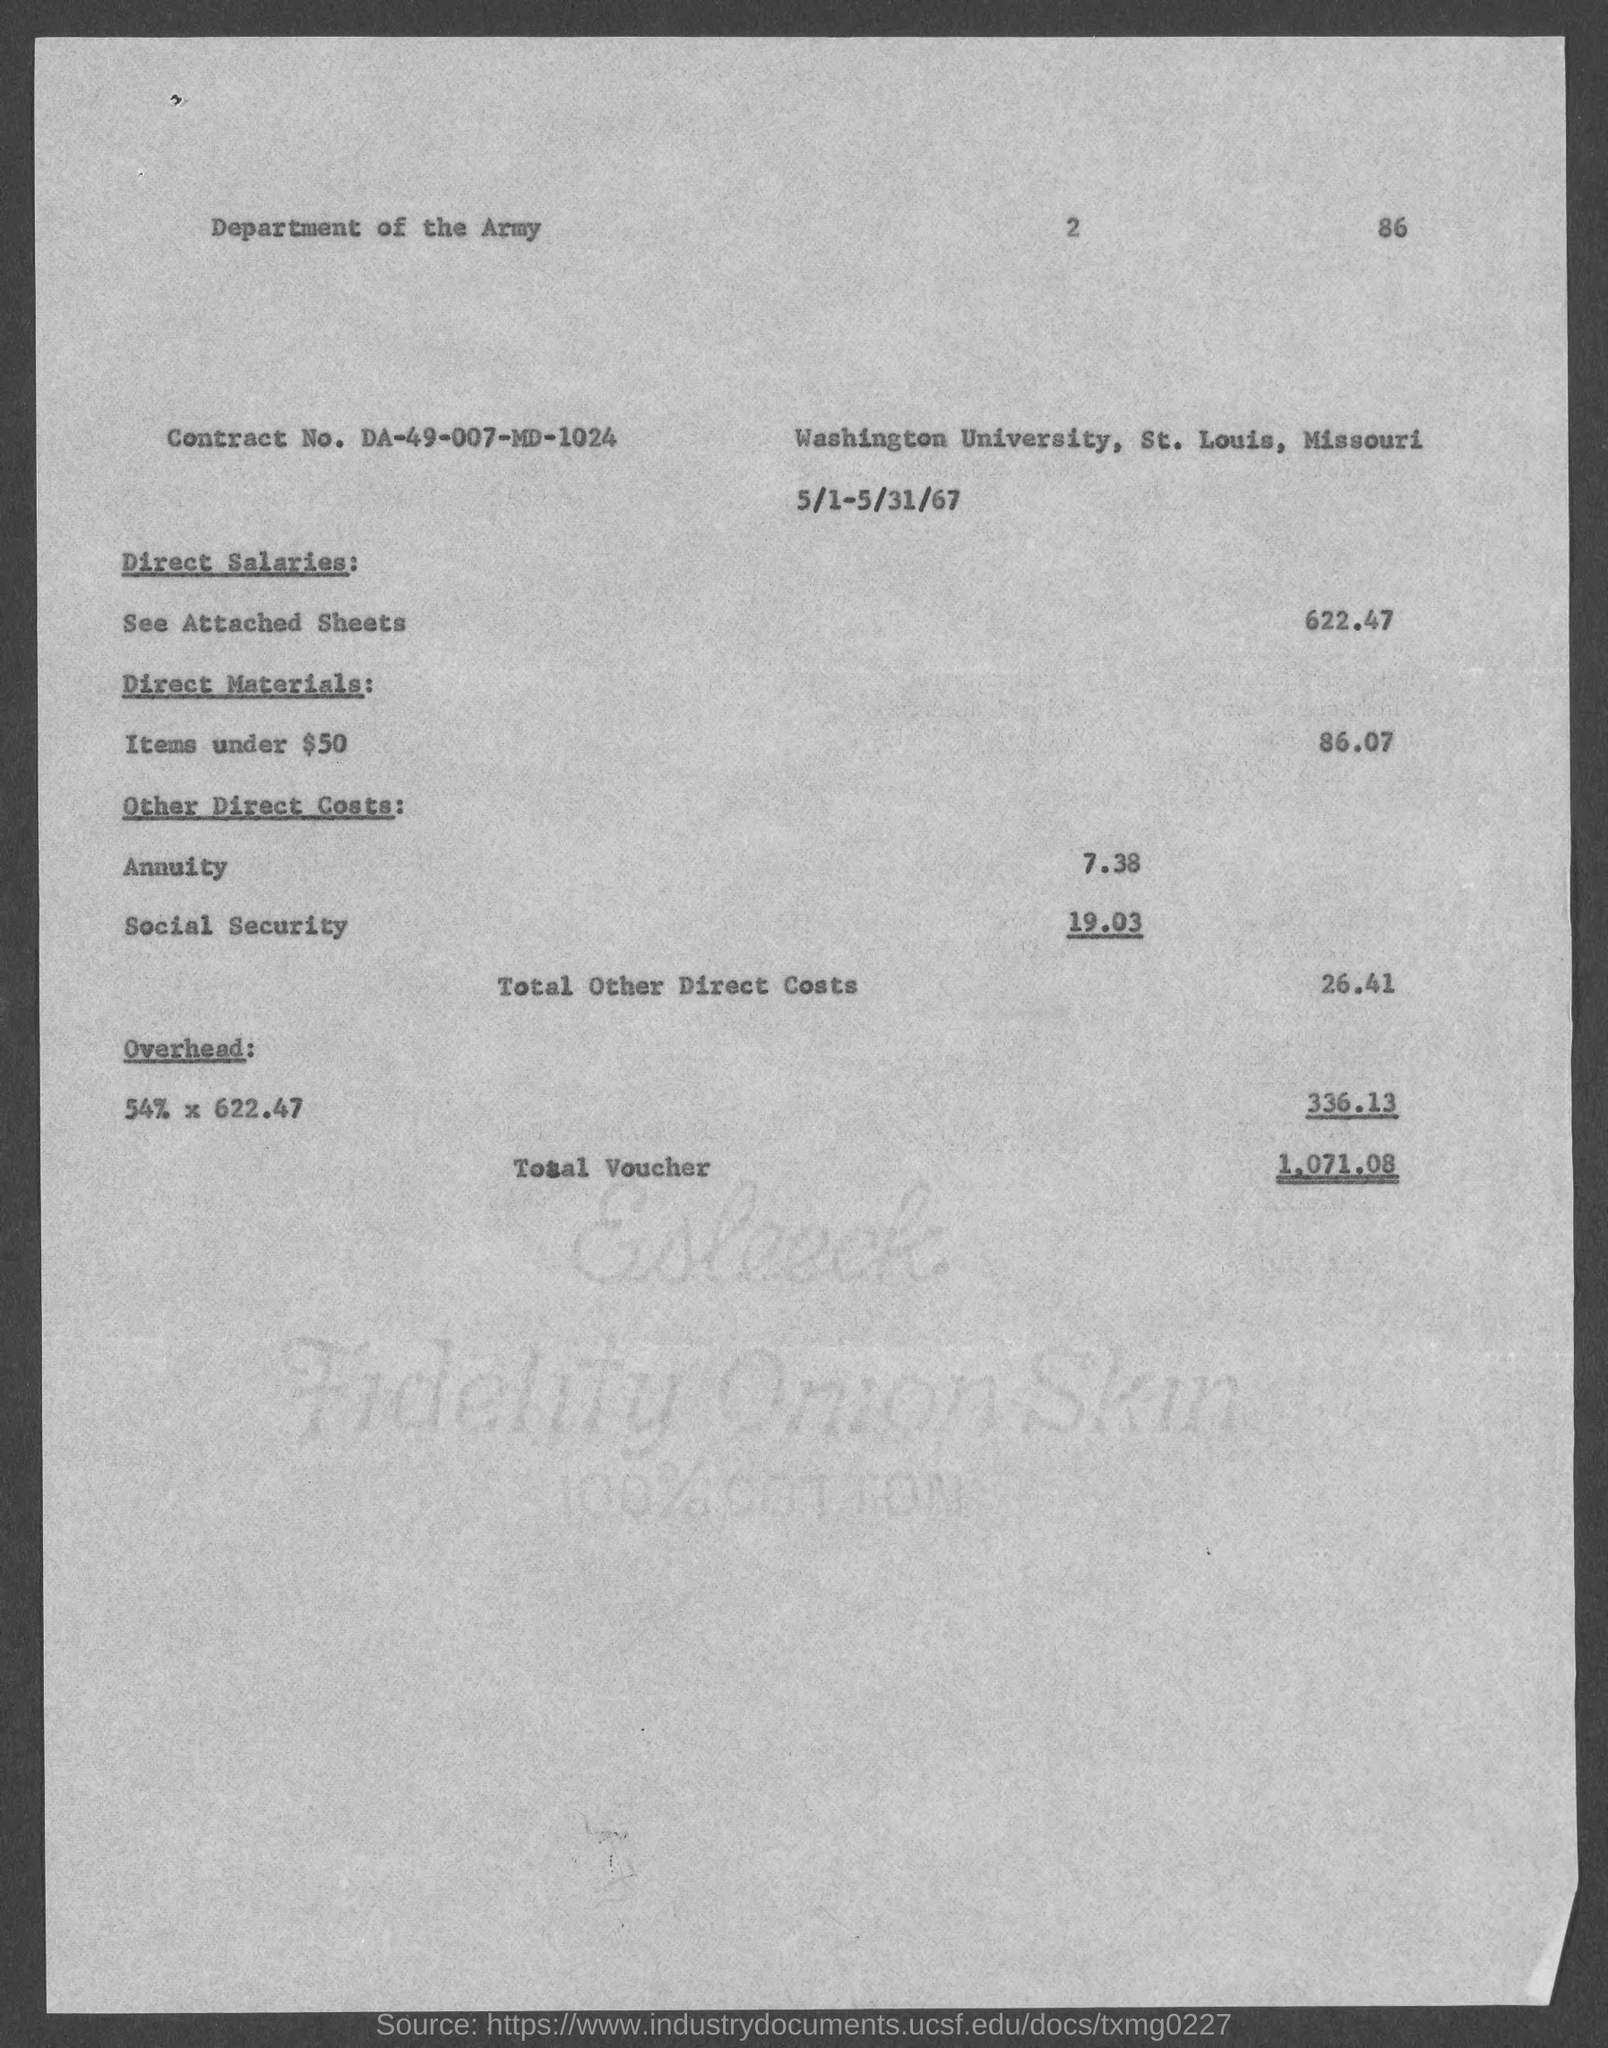Highlight a few significant elements in this photo. The total other direct costs are 26.41... The contract number is DA-49-007-MD-1024. The number in the top-right corner of the page is 86. The total voucher is 1,071.08. 